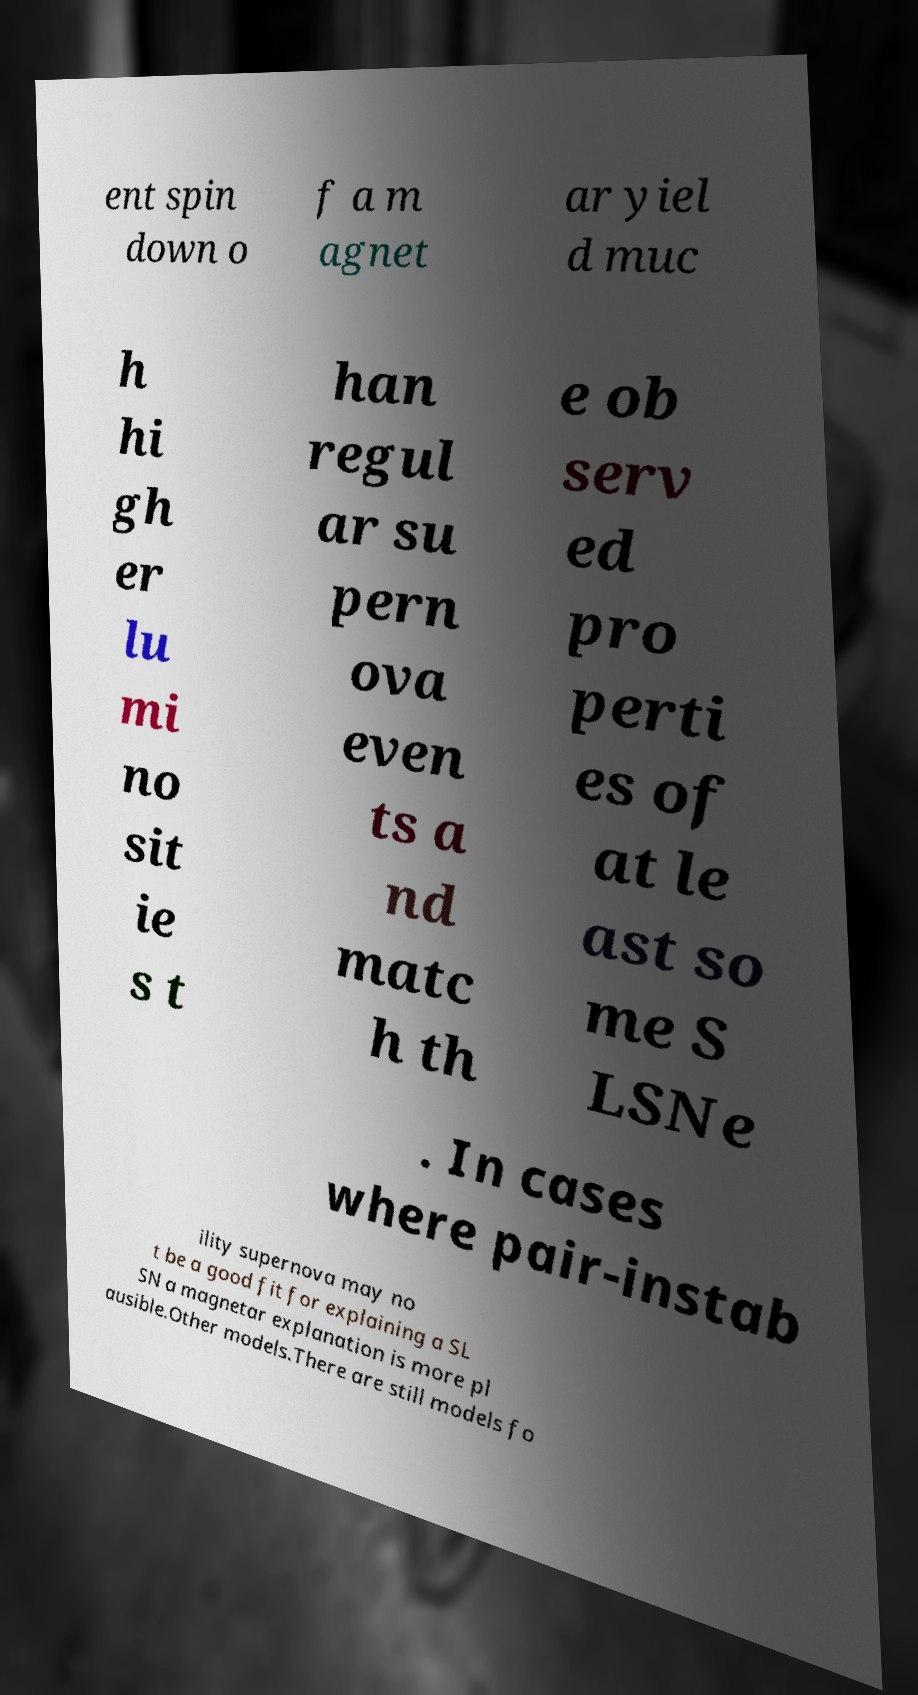Can you accurately transcribe the text from the provided image for me? ent spin down o f a m agnet ar yiel d muc h hi gh er lu mi no sit ie s t han regul ar su pern ova even ts a nd matc h th e ob serv ed pro perti es of at le ast so me S LSNe . In cases where pair-instab ility supernova may no t be a good fit for explaining a SL SN a magnetar explanation is more pl ausible.Other models.There are still models fo 